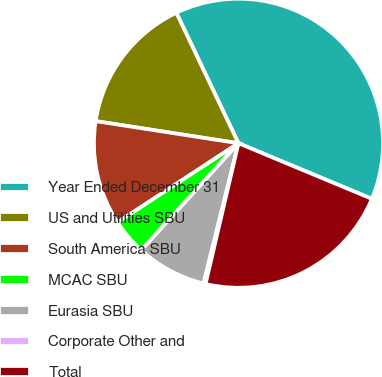<chart> <loc_0><loc_0><loc_500><loc_500><pie_chart><fcel>Year Ended December 31<fcel>US and Utilities SBU<fcel>South America SBU<fcel>MCAC SBU<fcel>Eurasia SBU<fcel>Corporate Other and<fcel>Total<nl><fcel>38.36%<fcel>15.48%<fcel>11.67%<fcel>4.04%<fcel>7.85%<fcel>0.23%<fcel>22.37%<nl></chart> 